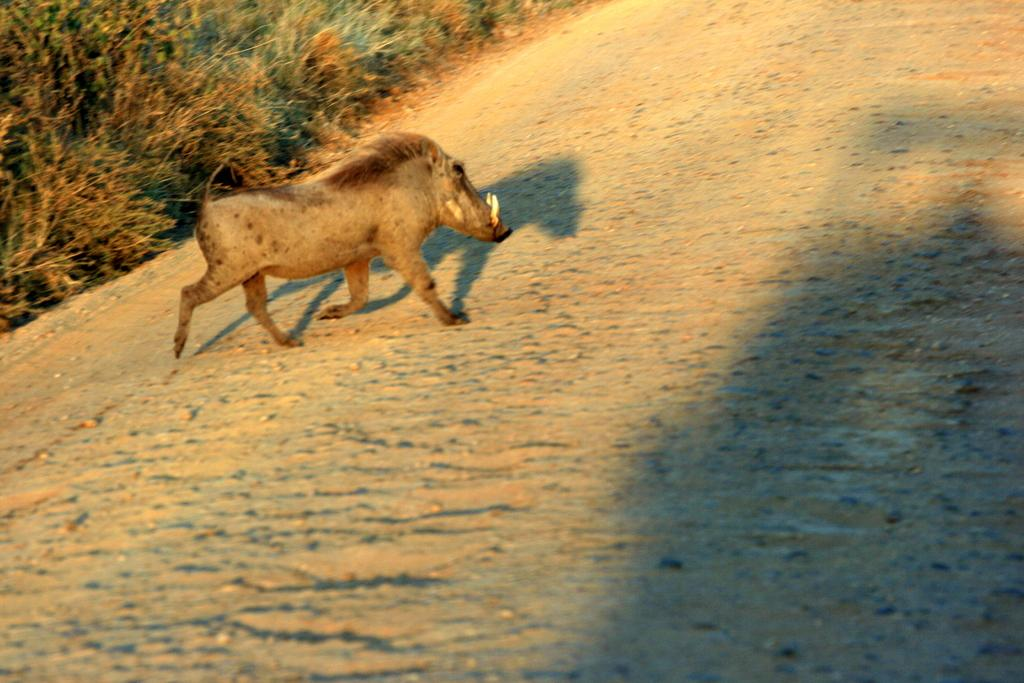What animal is present in the image? There is a wild boar in the image. What is the color of the wild boar? The wild boar is brown in color. What is the wild boar doing in the image? The wild boar is walking on the road. What can be seen on the left side of the image? There are plants on the ground on the left side of the image. What angle is the wall at in the image? There is no wall present in the image; it features a wild boar walking on the road with plants on the left side. 